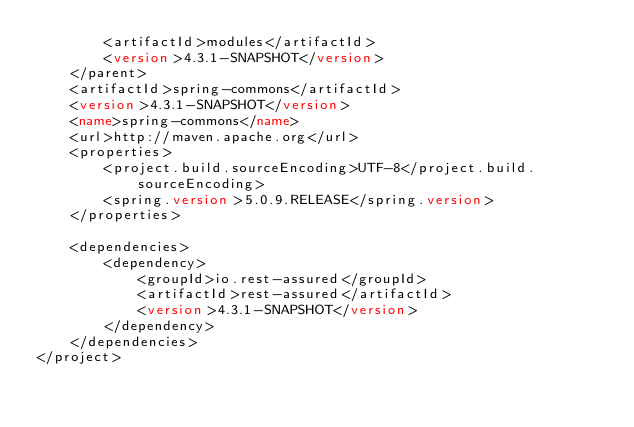<code> <loc_0><loc_0><loc_500><loc_500><_XML_>        <artifactId>modules</artifactId>
        <version>4.3.1-SNAPSHOT</version>
    </parent>
    <artifactId>spring-commons</artifactId>
    <version>4.3.1-SNAPSHOT</version>
    <name>spring-commons</name>
    <url>http://maven.apache.org</url>
    <properties>
        <project.build.sourceEncoding>UTF-8</project.build.sourceEncoding>
        <spring.version>5.0.9.RELEASE</spring.version>
    </properties>

    <dependencies>
        <dependency>
            <groupId>io.rest-assured</groupId>
            <artifactId>rest-assured</artifactId>
            <version>4.3.1-SNAPSHOT</version>
        </dependency>
    </dependencies>
</project></code> 